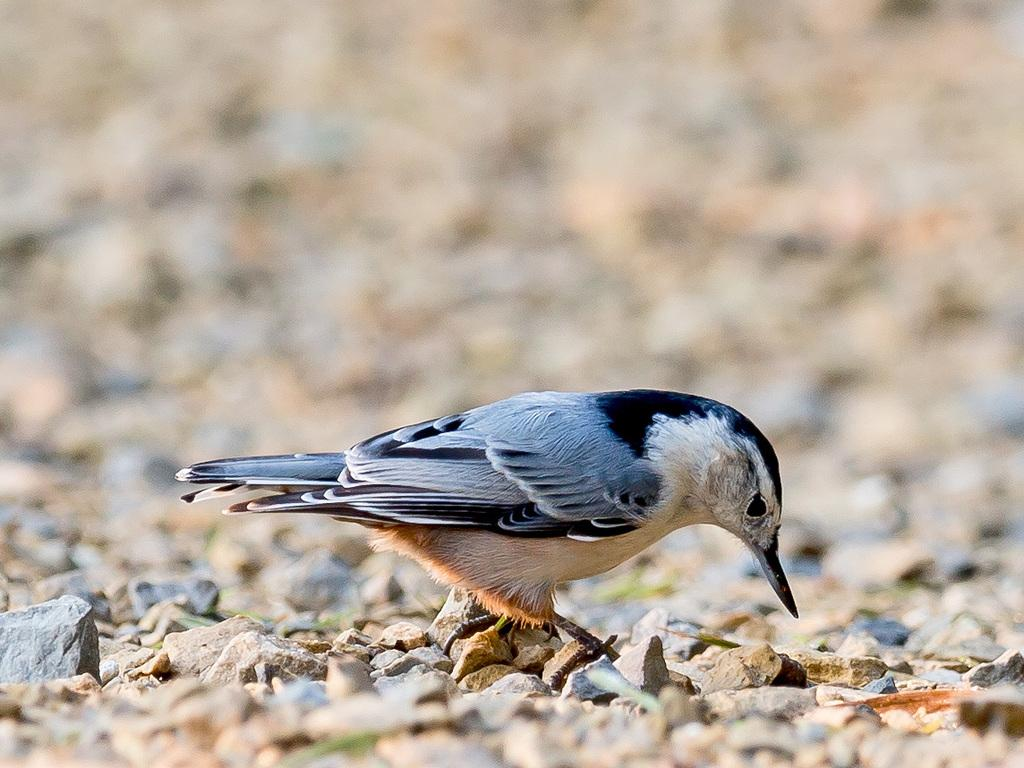What type of animal can be seen in the image? There is a bird in the image. Where is the bird located? The bird is standing on land. What can be found on the land where the bird is standing? The land has stones on it. What type of key is the bird holding in its beak in the image? There is no key present in the image; the bird is standing on land with stones. 